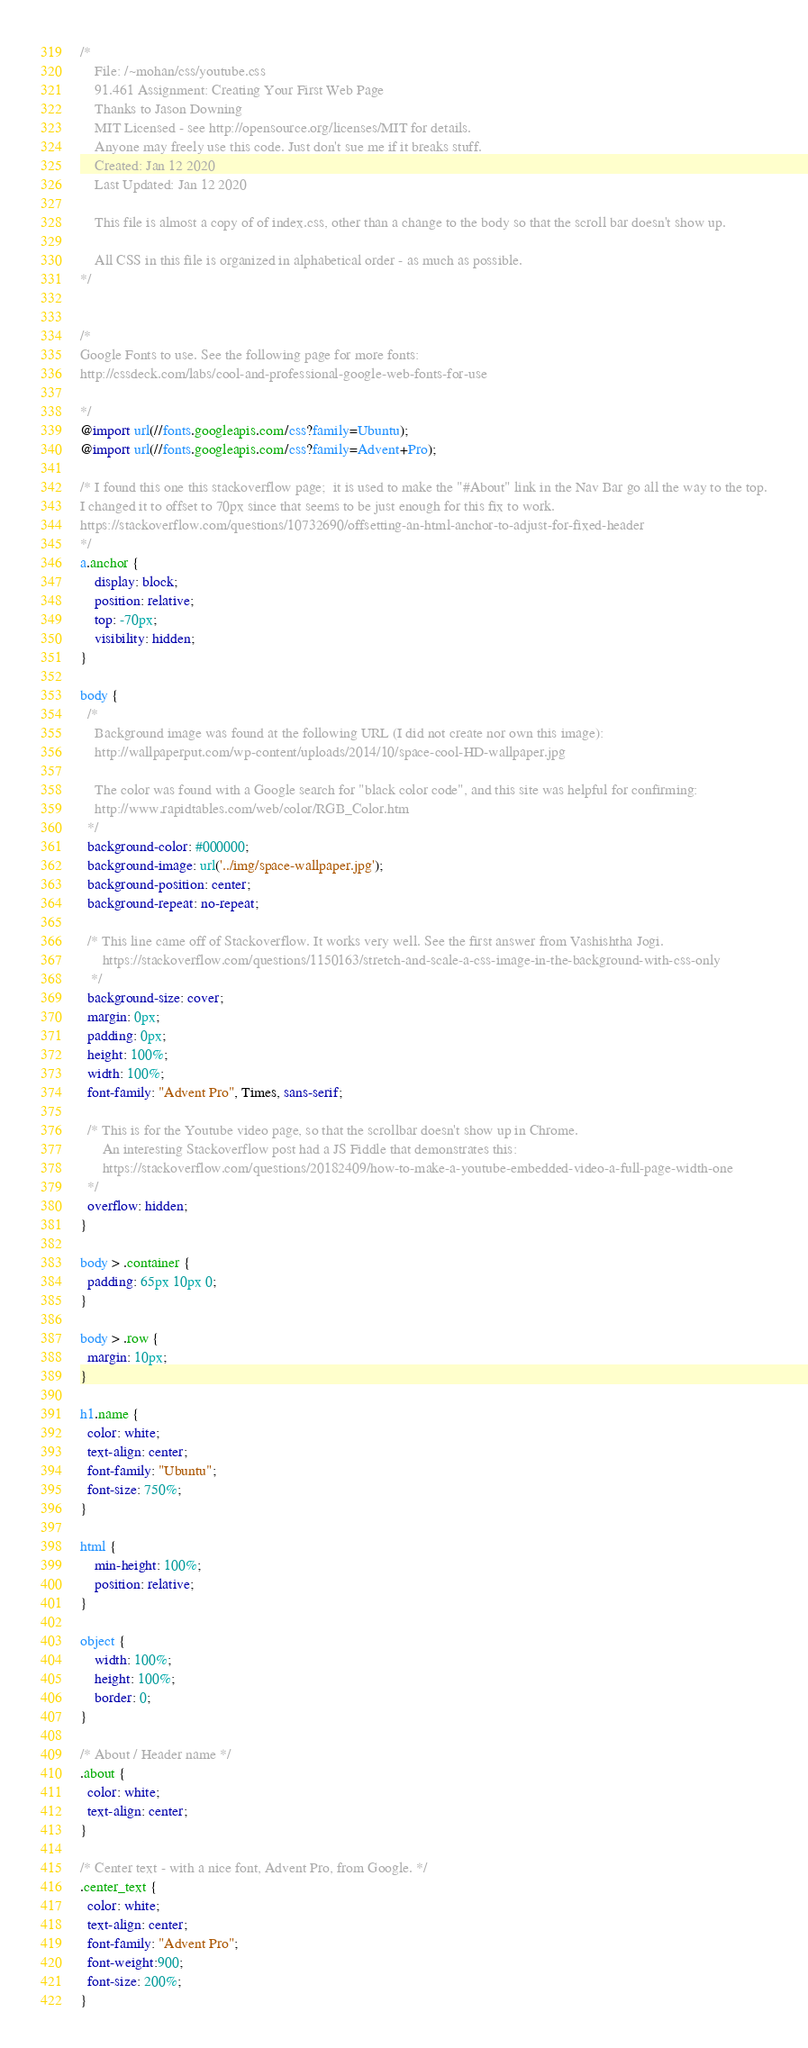<code> <loc_0><loc_0><loc_500><loc_500><_CSS_>/*
    File: /~mohan/css/youtube.css
    91.461 Assignment: Creating Your First Web Page
    Thanks to Jason Downing 
    MIT Licensed - see http://opensource.org/licenses/MIT for details.
    Anyone may freely use this code. Just don't sue me if it breaks stuff.
    Created: Jan 12 2020
    Last Updated: Jan 12 2020

    This file is almost a copy of of index.css, other than a change to the body so that the scroll bar doesn't show up.

    All CSS in this file is organized in alphabetical order - as much as possible.
*/


/*
Google Fonts to use. See the following page for more fonts:
http://cssdeck.com/labs/cool-and-professional-google-web-fonts-for-use

*/
@import url(//fonts.googleapis.com/css?family=Ubuntu);
@import url(//fonts.googleapis.com/css?family=Advent+Pro);

/* I found this one this stackoverflow page;  it is used to make the "#About" link in the Nav Bar go all the way to the top.
I changed it to offset to 70px since that seems to be just enough for this fix to work.
https://stackoverflow.com/questions/10732690/offsetting-an-html-anchor-to-adjust-for-fixed-header
*/
a.anchor {
    display: block;
    position: relative;
    top: -70px;
    visibility: hidden;
}

body {
  /*
    Background image was found at the following URL (I did not create nor own this image):
    http://wallpaperput.com/wp-content/uploads/2014/10/space-cool-HD-wallpaper.jpg

    The color was found with a Google search for "black color code", and this site was helpful for confirming:
    http://www.rapidtables.com/web/color/RGB_Color.htm
  */
  background-color: #000000;
  background-image: url('../img/space-wallpaper.jpg');
  background-position: center;
  background-repeat: no-repeat;

  /* This line came off of Stackoverflow. It works very well. See the first answer from Vashishtha Jogi.
      https://stackoverflow.com/questions/1150163/stretch-and-scale-a-css-image-in-the-background-with-css-only
   */
  background-size: cover;
  margin: 0px;
  padding: 0px;
  height: 100%;
  width: 100%;
  font-family: "Advent Pro", Times, sans-serif;

  /* This is for the Youtube video page, so that the scrollbar doesn't show up in Chrome.
      An interesting Stackoverflow post had a JS Fiddle that demonstrates this:
      https://stackoverflow.com/questions/20182409/how-to-make-a-youtube-embedded-video-a-full-page-width-one
  */
  overflow: hidden;
}

body > .container {
  padding: 65px 10px 0;
}

body > .row {
  margin: 10px;
}

h1.name {
  color: white;
  text-align: center;
  font-family: "Ubuntu";
  font-size: 750%;
}

html {
    min-height: 100%;
    position: relative;
}

object {
    width: 100%;
    height: 100%;
    border: 0;
}

/* About / Header name */
.about {
  color: white;
  text-align: center;
}

/* Center text - with a nice font, Advent Pro, from Google. */
.center_text {
  color: white;
  text-align: center;
  font-family: "Advent Pro";
  font-weight:900;
  font-size: 200%;
}
</code> 